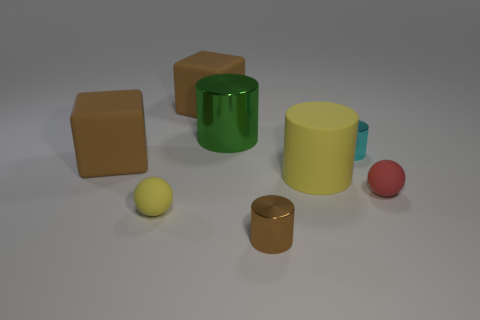There is a matte ball right of the brown metal thing; how big is it?
Make the answer very short. Small. The brown cylinder has what size?
Your answer should be very brief. Small. How many cubes are either large yellow rubber objects or big red matte things?
Your response must be concise. 0. What is the size of the red thing that is made of the same material as the yellow cylinder?
Provide a succinct answer. Small. How many small matte objects have the same color as the big rubber cylinder?
Your response must be concise. 1. Are there any big green shiny cylinders right of the large green object?
Make the answer very short. No. There is a small red thing; does it have the same shape as the brown thing that is to the right of the large green metallic cylinder?
Provide a succinct answer. No. What number of objects are either small brown things that are in front of the large green object or tiny shiny cylinders?
Make the answer very short. 2. Is there anything else that has the same material as the small red ball?
Make the answer very short. Yes. What number of things are both on the right side of the brown metal cylinder and to the left of the small cyan cylinder?
Make the answer very short. 1. 